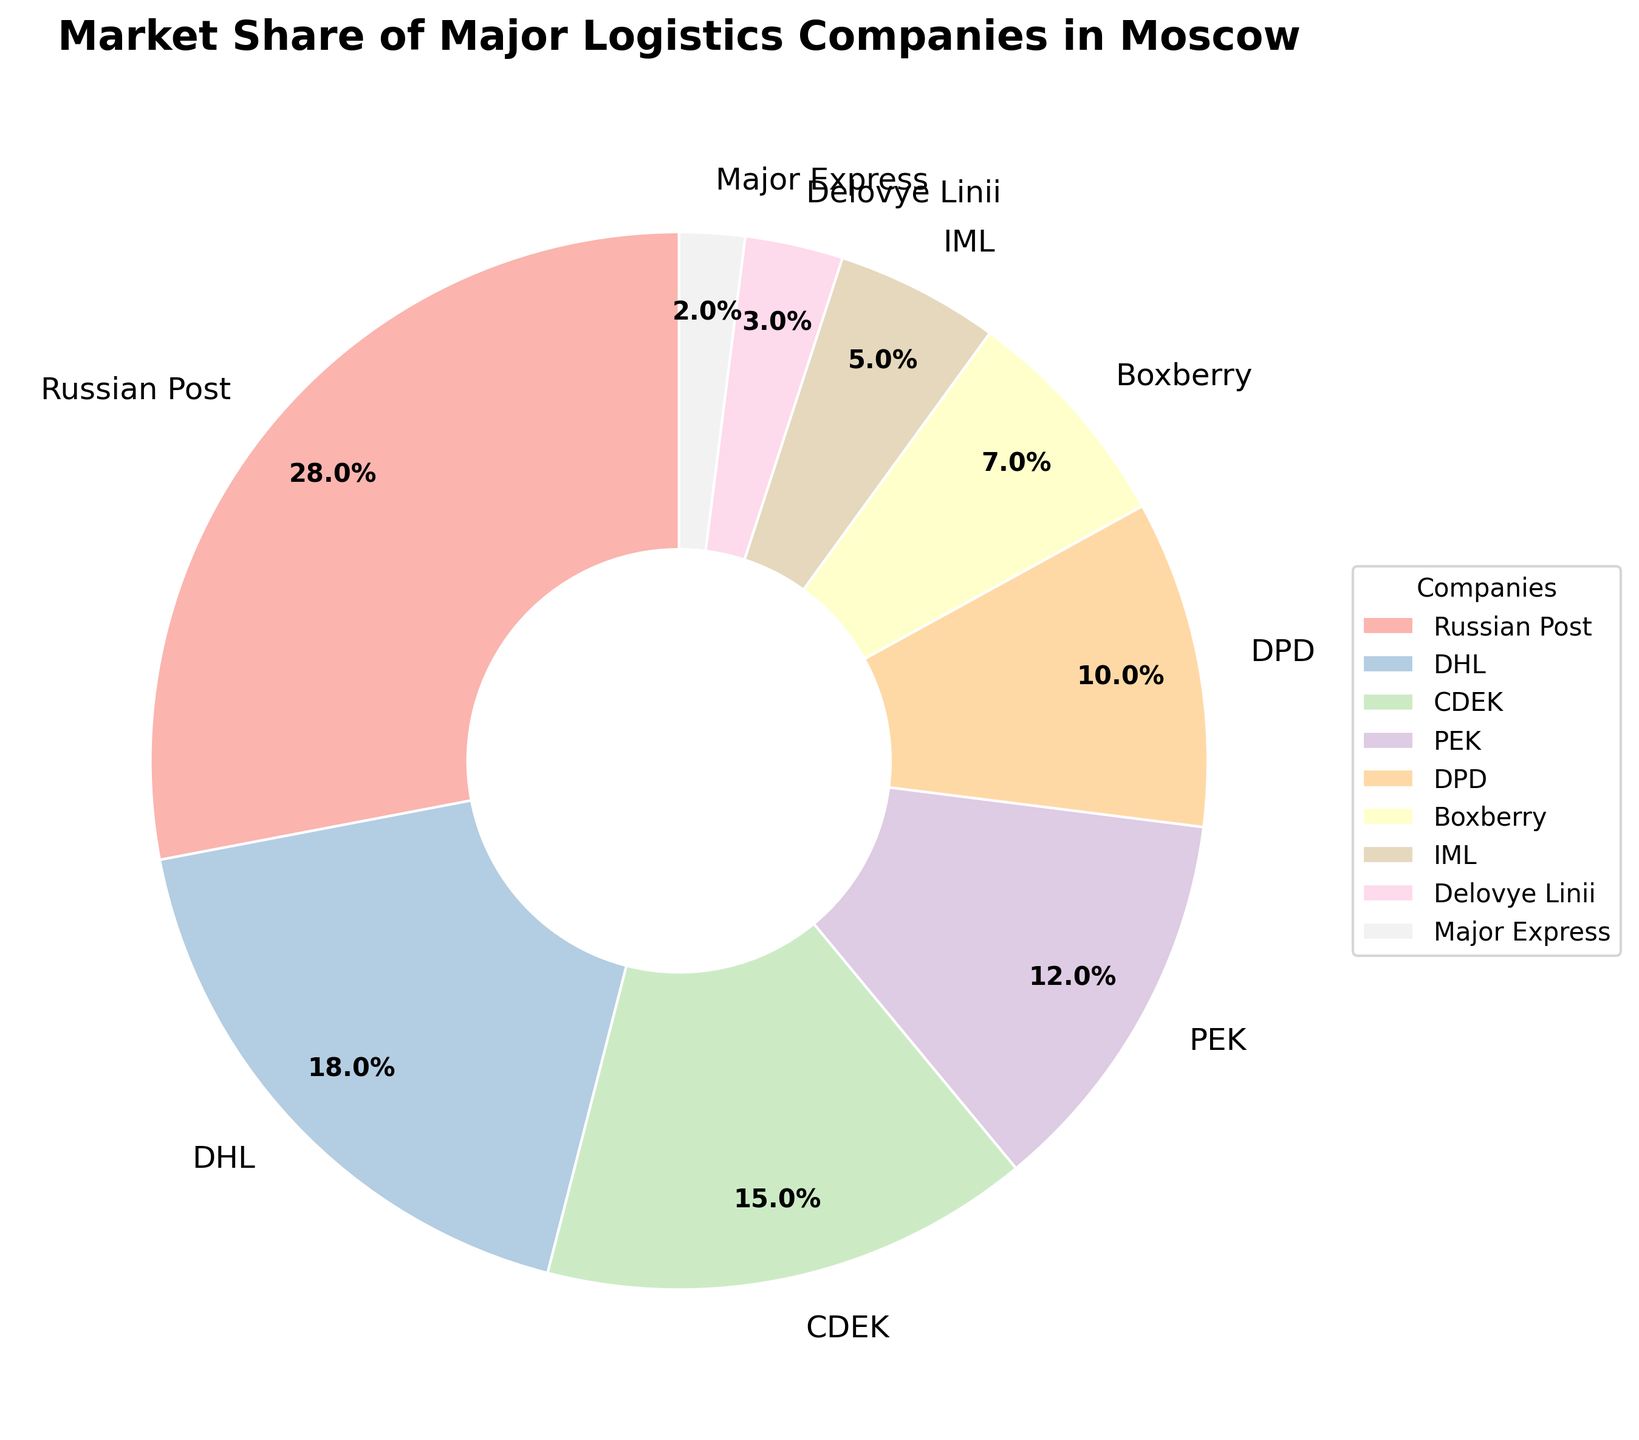Which company has the largest market share? The company slice occupying the largest section of the pie chart is indicative of the largest market share. The segment marked 'Russian Post' is the largest.
Answer: Russian Post Which two companies have a combined market share of 33%? By examining the percentages indicated on the slices, 'PEK' with 12% and 'DPD' with 10%, together with 'Boxberry' at 7%, sum to 12% + 10% + 7% = 29%, which does not match. But 'CDEK' with 15% added to 'DHL' with 18% makes 15% + 18% = 33%, which is exactly what is needed.
Answer: CDEK and DHL Is Russian Post's market share greater than the combined market share of DPD and Boxberry? Russian Post has 28%. DPD and Boxberry together have 10% + 7% = 17%. Basic comparison shows that 28% > 17%.
Answer: Yes Which companies have market shares less than 10%? The segments labeled 'IML', 'Delovye Linii', and 'Major Express' have shares of 5%, 3%, and 2%, all of which are less than 10%.
Answer: IML, Delovye Linii, Major Express How much larger is the market share of Russian Post compared to CDEK? Russian Post has 28%, and CDEK has 15%. The difference is calculated as 28% - 15% = 13%.
Answer: 13% Which company has a red-colored slice? Since the color descriptions are not given in the data, we rely on visual identification. The red-colored slice corresponds to the company section with visual attributes identifiable by eye if available, but cannot conclusively answer without the visual graph.
Answer: Cannot determine What is the total market share of the top three companies? The top three companies as per the largest segments are 'Russian Post' (28%), 'DHL' (18%), and 'CDEK' (15%). Summing these values gives 28% + 18% + 15% = 61%.
Answer: 61% Is the market share of PEK more than twice that of IML? PEK has 12% whereas IML has 5%. Twice of IML is 5% * 2 = 10%. Since 12% > 10%, the condition is satisfied.
Answer: Yes Which company has the smallest market share and what is it? Based on the smallest segment, 'Major Express' is identified with a 2% market share.
Answer: Major Express, 2% 